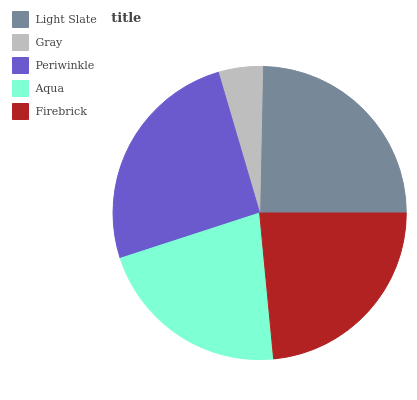Is Gray the minimum?
Answer yes or no. Yes. Is Periwinkle the maximum?
Answer yes or no. Yes. Is Periwinkle the minimum?
Answer yes or no. No. Is Gray the maximum?
Answer yes or no. No. Is Periwinkle greater than Gray?
Answer yes or no. Yes. Is Gray less than Periwinkle?
Answer yes or no. Yes. Is Gray greater than Periwinkle?
Answer yes or no. No. Is Periwinkle less than Gray?
Answer yes or no. No. Is Firebrick the high median?
Answer yes or no. Yes. Is Firebrick the low median?
Answer yes or no. Yes. Is Gray the high median?
Answer yes or no. No. Is Gray the low median?
Answer yes or no. No. 